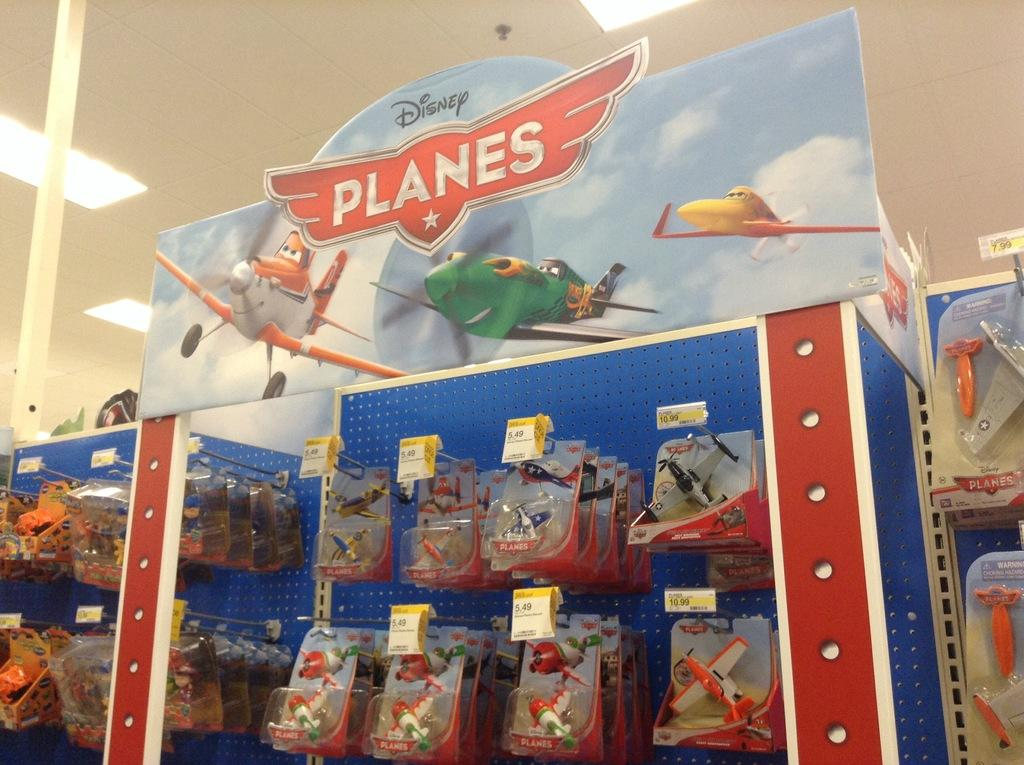What type of toys are present in the image? There are helicopter toys in the image. What is used for writing or drawing in the image? There are cost plates in the image, which can be used for writing or drawing. What can be seen hanging in the image? There is a banner in the image. What is written or printed in the image? There is text in the image. What other objects can be seen in the image besides the helicopter toys, cost plates, and banner? There are other objects in the image. What type of lighting is present in the image? There are lights on the ceiling in the image. What type of truck is visible in the image? There is no truck present in the image. What type of zipper can be seen on the cost plates in the image? There are no zippers present on the cost plates in the image. 